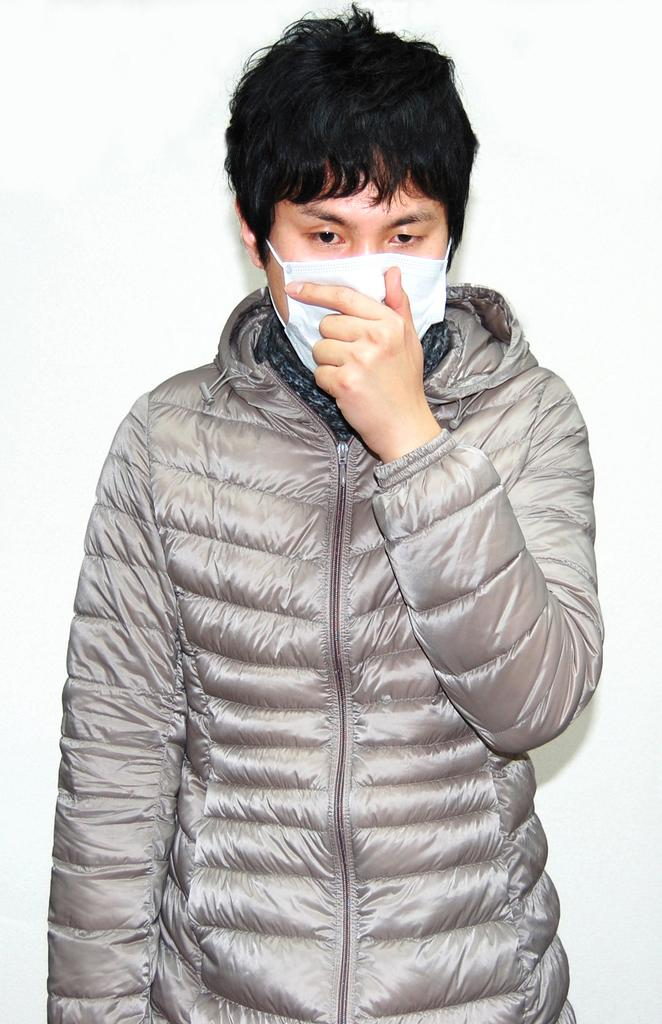Who or what is present in the image? There is a person in the image. Can you describe the person's appearance? The person is wearing a mask. What type of sleet can be seen falling in the image? There is no sleet present in the image; it only features a person wearing a mask. How does the person's slave status affect their appearance in the image? There is no mention of a slave status or any indication of it in the image, so we cannot determine its effect on the person's appearance. 